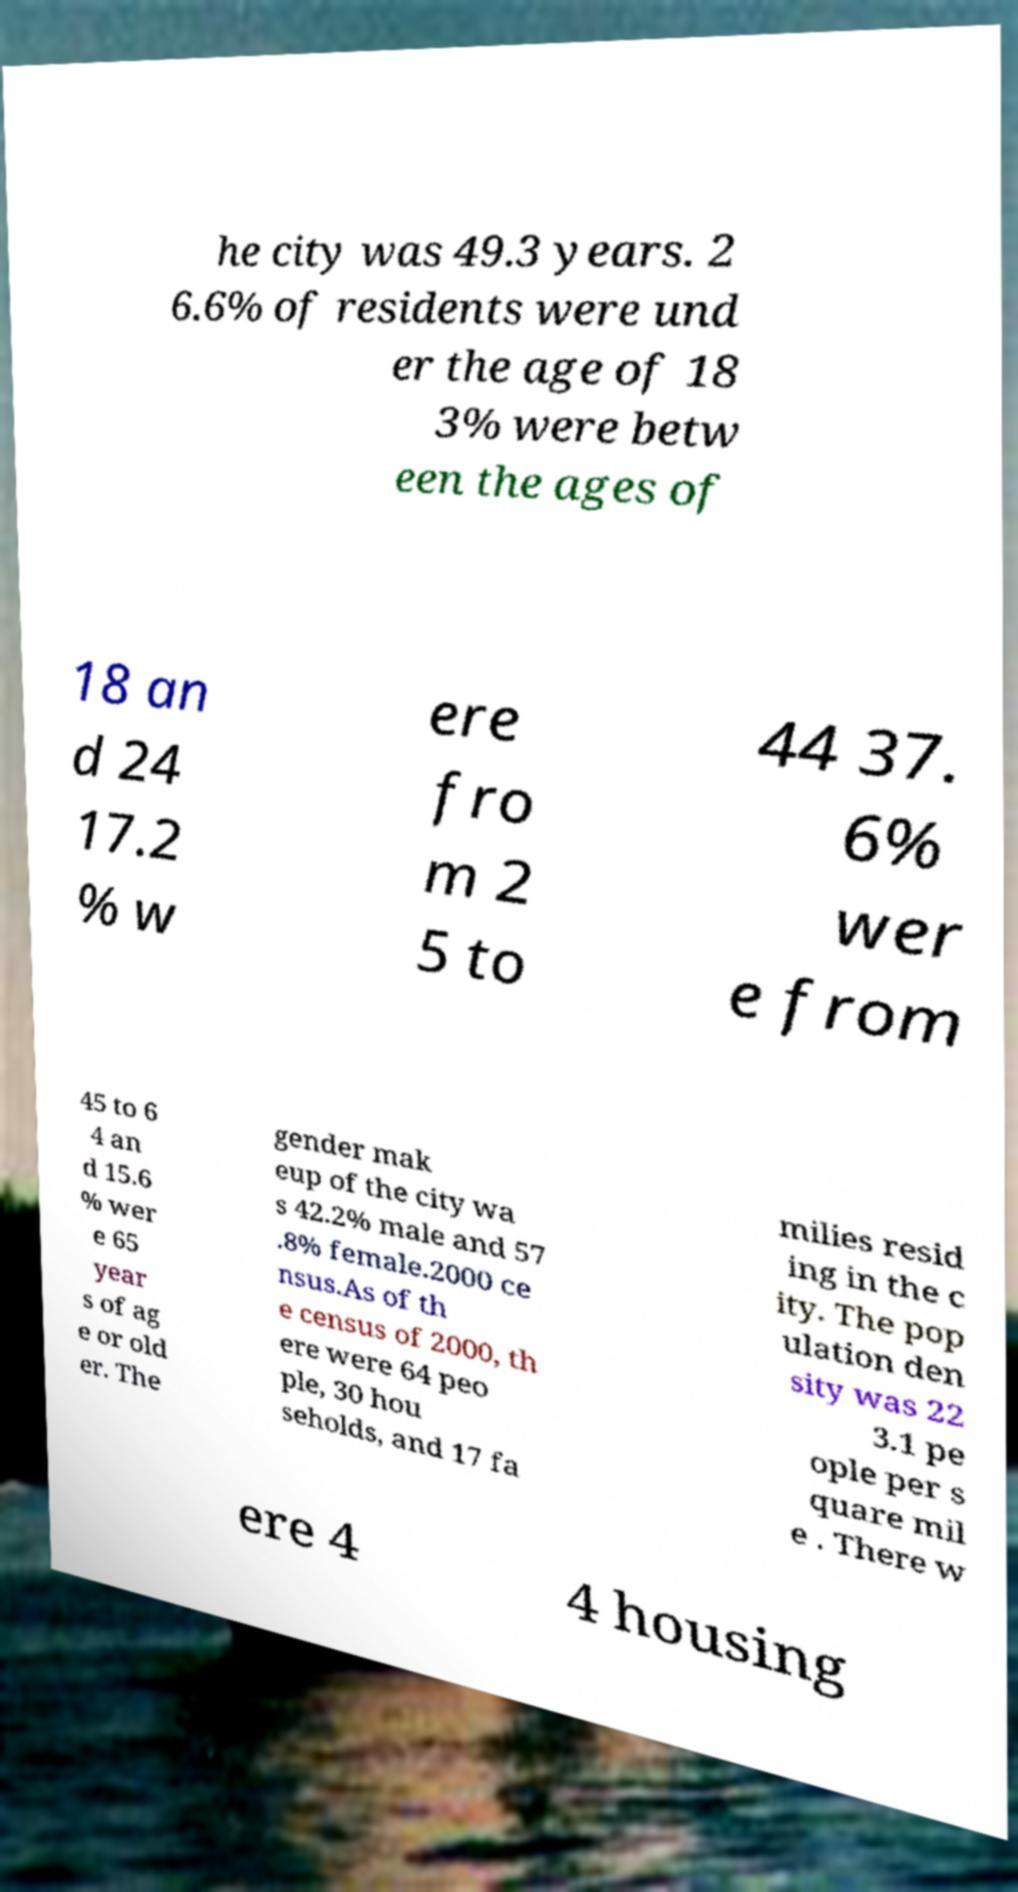For documentation purposes, I need the text within this image transcribed. Could you provide that? he city was 49.3 years. 2 6.6% of residents were und er the age of 18 3% were betw een the ages of 18 an d 24 17.2 % w ere fro m 2 5 to 44 37. 6% wer e from 45 to 6 4 an d 15.6 % wer e 65 year s of ag e or old er. The gender mak eup of the city wa s 42.2% male and 57 .8% female.2000 ce nsus.As of th e census of 2000, th ere were 64 peo ple, 30 hou seholds, and 17 fa milies resid ing in the c ity. The pop ulation den sity was 22 3.1 pe ople per s quare mil e . There w ere 4 4 housing 